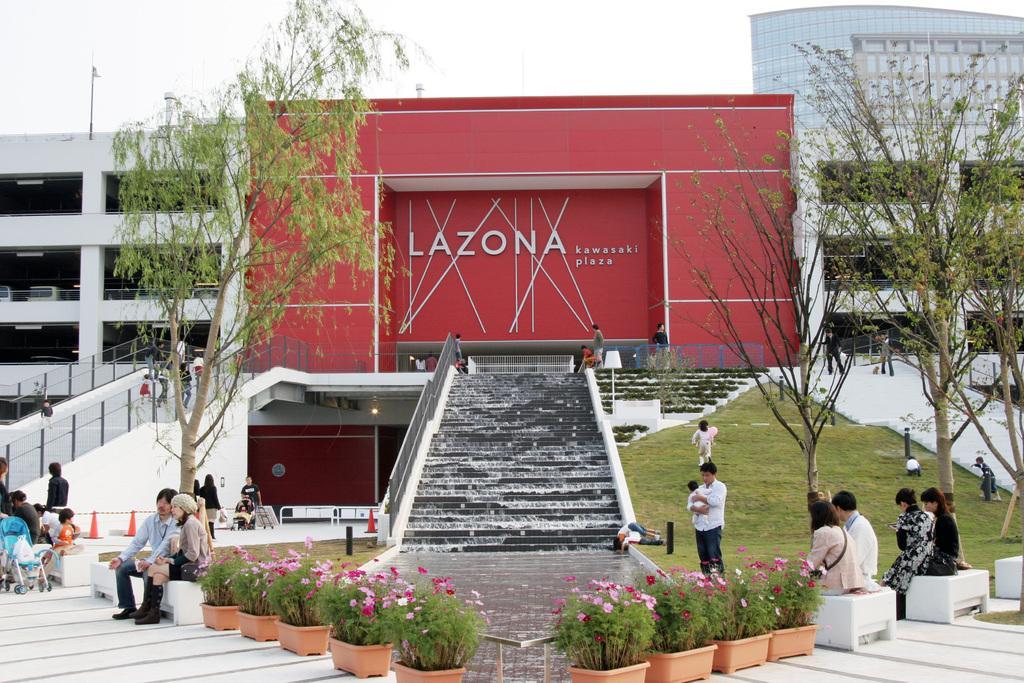Can you describe this image briefly? This picture describes about group of people, few are seated and few are standing, behind them we can see few plants and trees, in the background we can see few metal rods and buildings. 